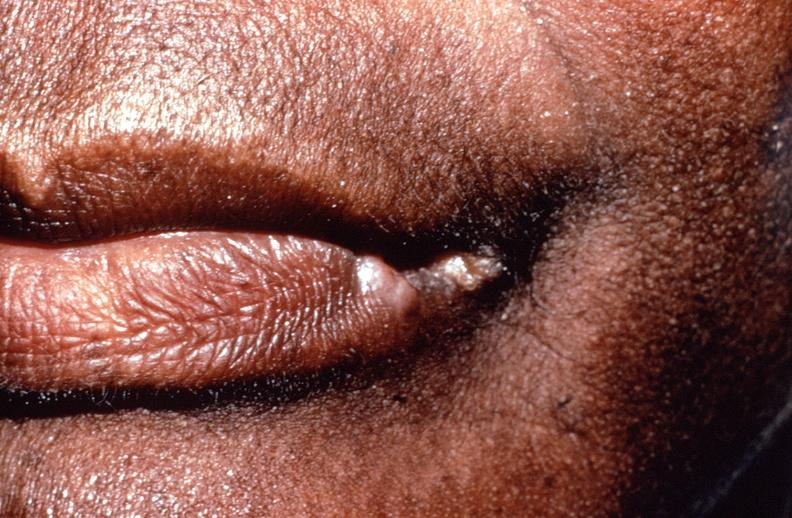what is present?
Answer the question using a single word or phrase. Gastrointestinal 